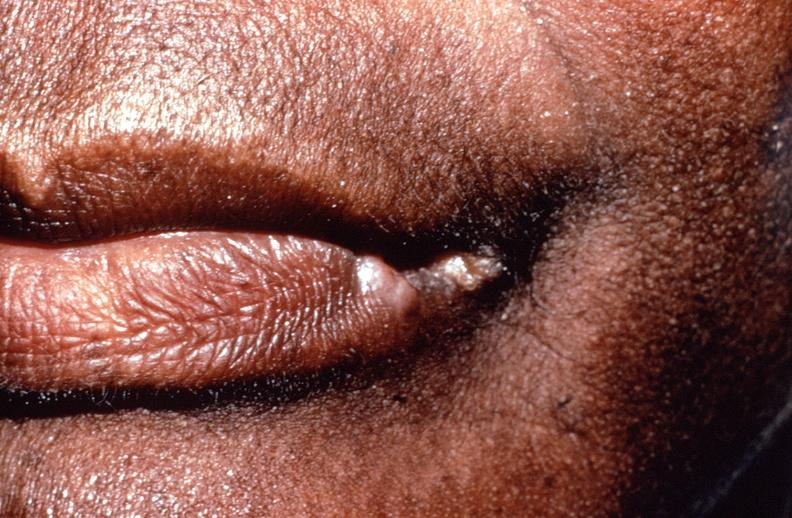what is present?
Answer the question using a single word or phrase. Gastrointestinal 